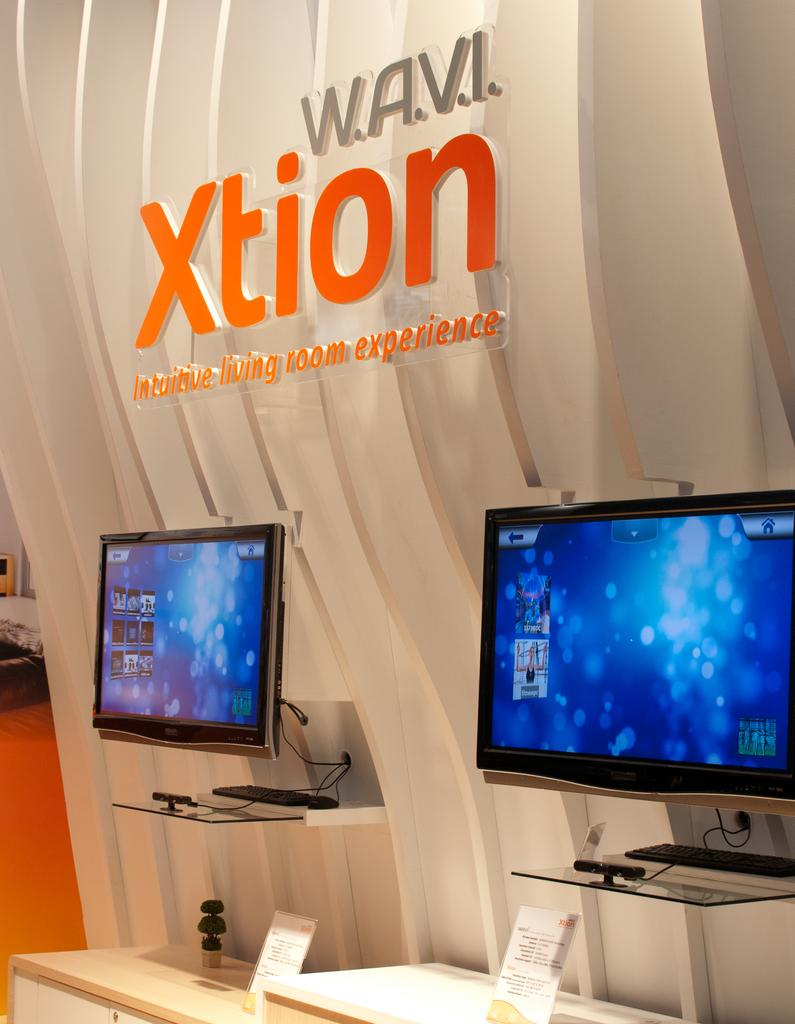<image>
Render a clear and concise summary of the photo. Computer monitors on display under a sign for the W.A.V.I. Xtion Intuitive Living Room Experience brand. 